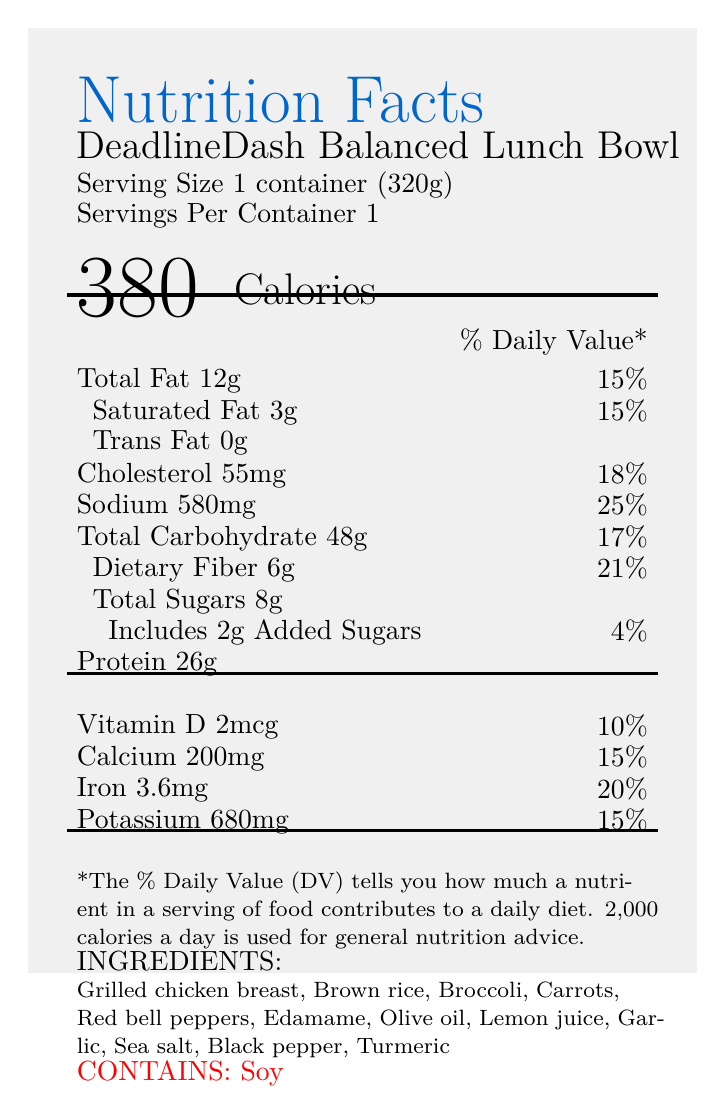what is the serving size of the DeadlineDash Balanced Lunch Bowl? The serving size is listed on the document as "Serving Size 1 container (320g)".
Answer: 1 container (320g) how many calories does the DeadlineDash Balanced Lunch Bowl contain? The document indicates the calorie content next to the bold "Calories" label, which is listed as 380.
Answer: 380 calories what is the percentage of Daily Value for total fat in the meal? The percentage of Daily Value for total fat is located next to "Total Fat 12g" and is shown as 15%.
Answer: 15% how much dietary fiber is in the meal? The amount of dietary fiber is listed directly under "Dietary Fiber", which notes it as 6g.
Answer: 6g what are the allergens contained in this meal? The document specifies allergens at the bottom with "CONTAINS: Soy".
Answer: Soy which vitamin is included at 10% of the Daily Value? A. Vitamin A B. Vitamin D C. Vitamin C D. Vitamin B12 The document lists "Vitamin D 2mcg" with a Daily Value percentage of 10%.
Answer: B. Vitamin D what percentage of the Daily Value does sodium contribute in this meal? A. 18% B. 21% C. 25% D. 28% The document states next to "Sodium 580mg" a percentage of 25% Daily Value.
Answer: C. 25% does this meal contain trans fat? The document lists "Trans Fat 0g", indicating it does not contain trans fat.
Answer: No summarize the main purpose of the DeadlineDash Balanced Lunch Bowl as described in the document. The document describes the product as specially crafted for busy professionals who need a quick, nutritious meal to sustain their energy and focus. It emphasizes its balanced composition of protein, carbohydrates, and vegetables.
Answer: The DeadlineDash Balanced Lunch Bowl is designed for busy professionals needing a nutritious, quick meal to stay energized and focused during tight deadlines. It offers balanced nutrition with lean protein, complex carbohydrates, and fiber-rich vegetables. what are the heating instructions for this meal? The document specifies how to heat the meal, stating to microwave on high for 3-4 minutes, stir halfway through, and let it stand for 1 minute before consuming.
Answer: Microwave on high for 3-4 minutes, stirring halfway through. Let stand for 1 minute before enjoying. what is the serving size in ounces? The document only provides the serving size in grams (320g), and does not give enough information for conversion to ounces.
Answer: Cannot be determined how much added sugars are in the meal and what percentage of the Daily Value does it contribute? The document lists "Includes 2g Added Sugars" immediately followed by "4%" for Daily Value.
Answer: 2g (4%) is the DeadlineDash Balanced Lunch Bowl suitable for vegetarians? Since "Grilled chicken breast" is listed among the ingredients, the meal is not suitable for vegetarians.
Answer: No 